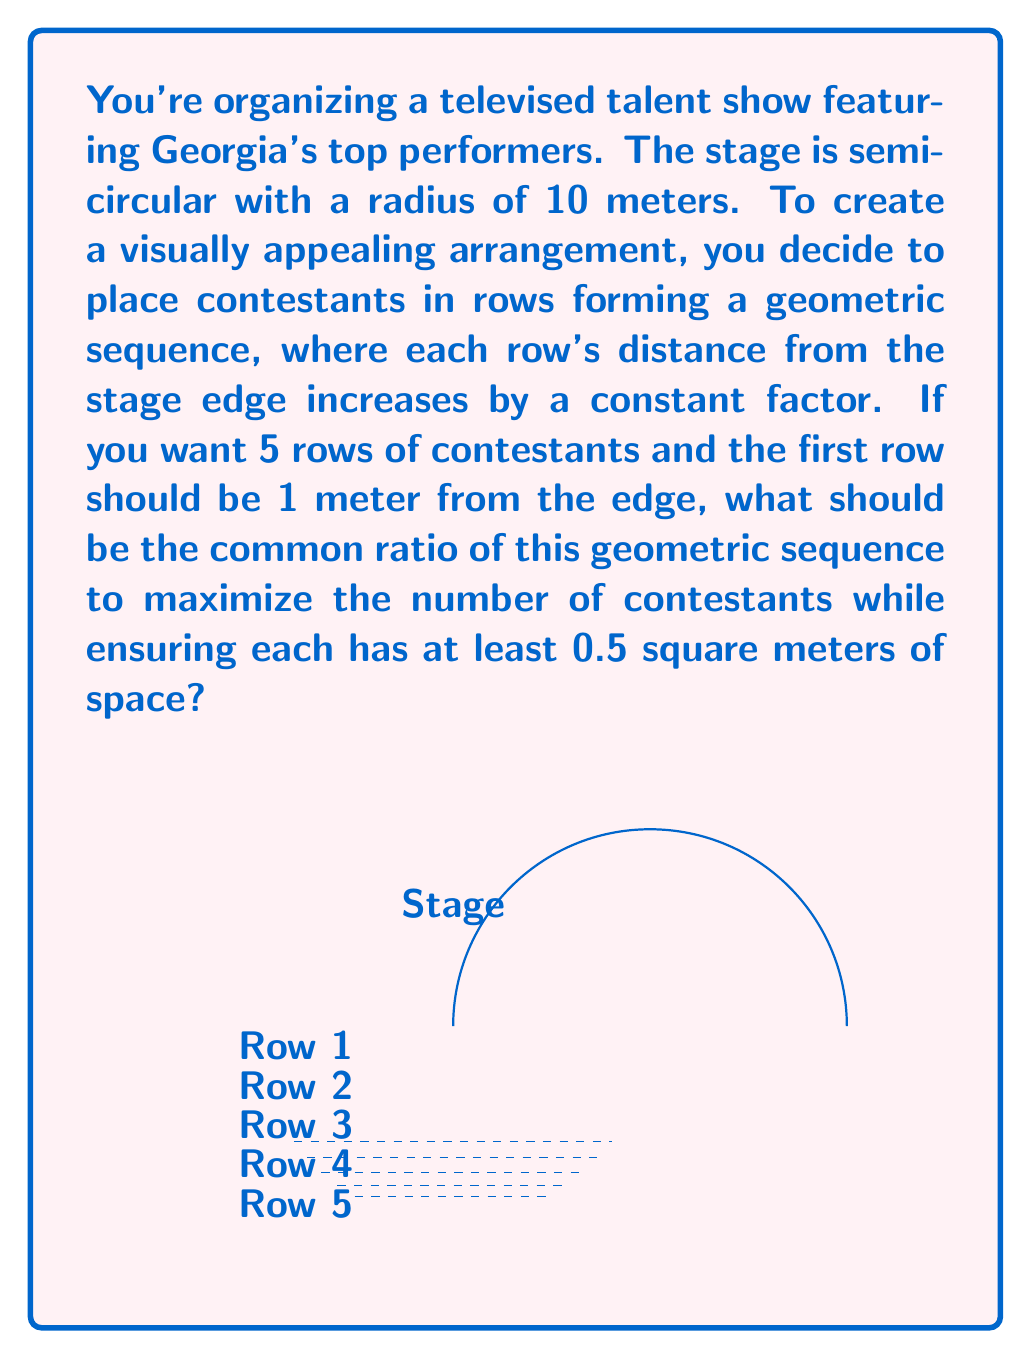Provide a solution to this math problem. Let's approach this step-by-step:

1) Let the common ratio of the geometric sequence be $r$. The distances of the rows from the edge will be:
   $$1, r, r^2, r^3, r^4$$

2) The area of each semicircular ring can be calculated as:
   $$A_n = \pi((10-d_{n-1})^2 - (10-d_n)^2)$$
   where $d_n$ is the distance of the nth row from the edge.

3) For the 5th (last) row:
   $$d_5 = 1 + r + r^2 + r^3 + r^4 = \frac{r^5-1}{r-1}$$

4) We want to maximize the number of contestants, which means maximizing the total area divided by 0.5 (the space per contestant). This is equivalent to maximizing the total area.

5) The total area is:
   $$A_{total} = \pi(10^2 - (10-\frac{r^5-1}{r-1})^2)$$

6) To find the maximum, we differentiate with respect to $r$ and set it to zero:
   $$\frac{dA_{total}}{dr} = 2\pi(10-\frac{r^5-1}{r-1})\frac{5r^4(r-1)-(r^5-1)}{(r-1)^2} = 0$$

7) Solving this equation numerically (as it's complex to solve analytically) gives us $r \approx 1.27$.

8) We can verify this is a maximum by checking the second derivative is negative at this point.
Answer: $r \approx 1.27$ 